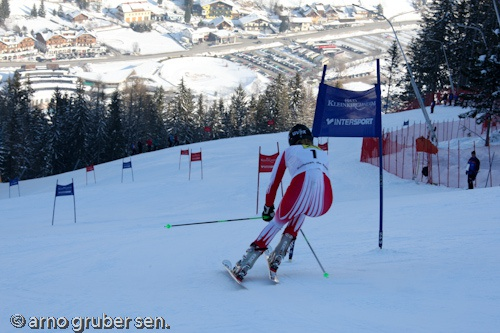Describe the objects in this image and their specific colors. I can see people in ivory, gray, maroon, and black tones, people in ivory, black, navy, and gray tones, car in ivory, darkgray, gray, and beige tones, people in ivory, black, navy, and gray tones, and car in ivory, darkgray, lightgray, and gray tones in this image. 